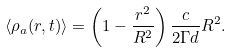<formula> <loc_0><loc_0><loc_500><loc_500>\langle \rho _ { a } ( r , t ) \rangle = \left ( 1 - \frac { r ^ { 2 } } { R ^ { 2 } } \right ) \frac { c } { 2 \Gamma d } R ^ { 2 } .</formula> 